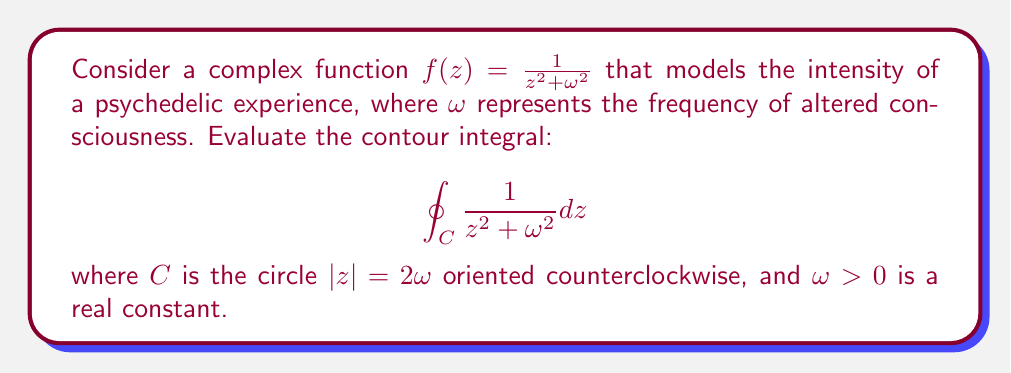Can you solve this math problem? To evaluate this contour integral, we'll use the Residue Theorem. The steps are as follows:

1) First, we need to find the poles of the function inside the contour. The poles are at $z = \pm i\omega$.

2) Since $|z| = 2\omega$, both poles lie inside the contour.

3) Let's calculate the residues at these poles:

   At $z = i\omega$:
   $$\text{Res}(f, i\omega) = \lim_{z \to i\omega} (z - i\omega)\frac{1}{z^2 + \omega^2} = \frac{1}{2i\omega}$$

   At $z = -i\omega$:
   $$\text{Res}(f, -i\omega) = \lim_{z \to -i\omega} (z + i\omega)\frac{1}{z^2 + \omega^2} = -\frac{1}{2i\omega}$$

4) The Residue Theorem states that for a function $f(z)$ that is analytic except for isolated singularities inside a simple closed contour $C$:

   $$\oint_C f(z) dz = 2\pi i \sum \text{Res}(f, a_k)$$

   where $a_k$ are the singularities of $f(z)$ inside $C$.

5) Applying the Residue Theorem:

   $$\oint_C \frac{1}{z^2 + \omega^2} dz = 2\pi i \left(\frac{1}{2i\omega} - \frac{1}{2i\omega}\right) = 0$$

Thus, the contour integral evaluates to zero.
Answer: The value of the contour integral is 0. 